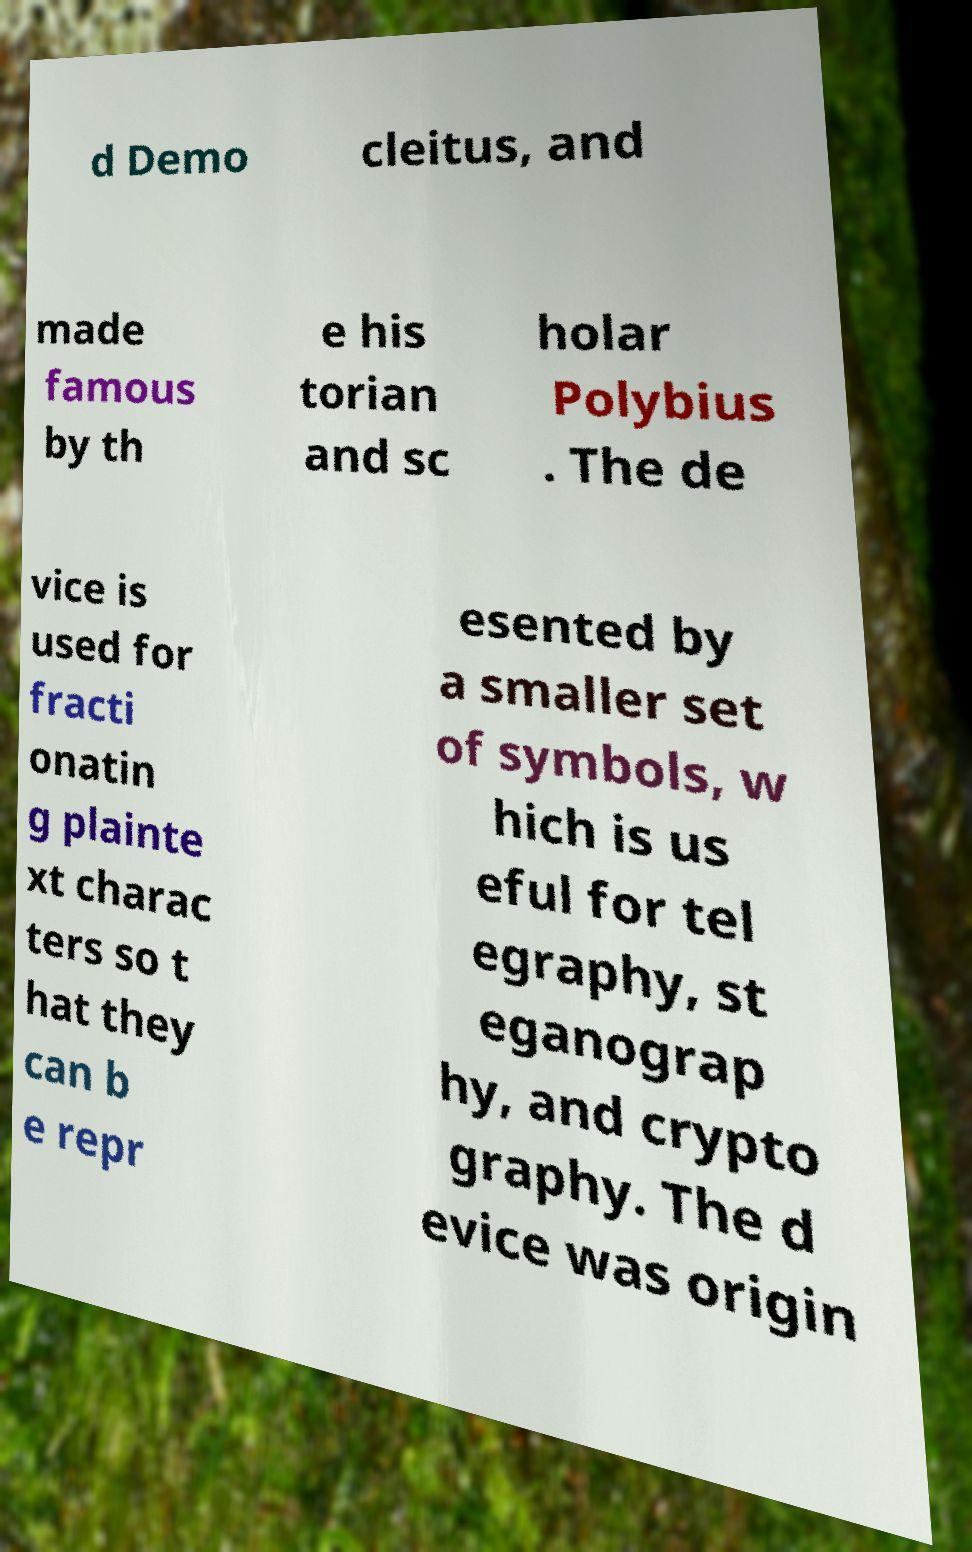There's text embedded in this image that I need extracted. Can you transcribe it verbatim? d Demo cleitus, and made famous by th e his torian and sc holar Polybius . The de vice is used for fracti onatin g plainte xt charac ters so t hat they can b e repr esented by a smaller set of symbols, w hich is us eful for tel egraphy, st eganograp hy, and crypto graphy. The d evice was origin 